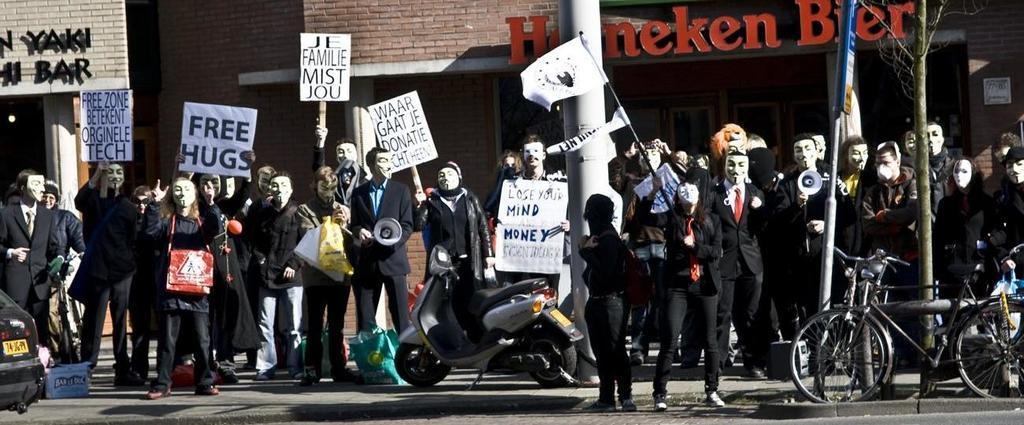How would you summarize this image in a sentence or two? In this image there is a road. There are cycles on the right side. There is a scooter. There is a car on the left side. There are people wearing a face mask are standing. They are holding some banners and flags. There are buildings in the background. There is a tree on the right side. 